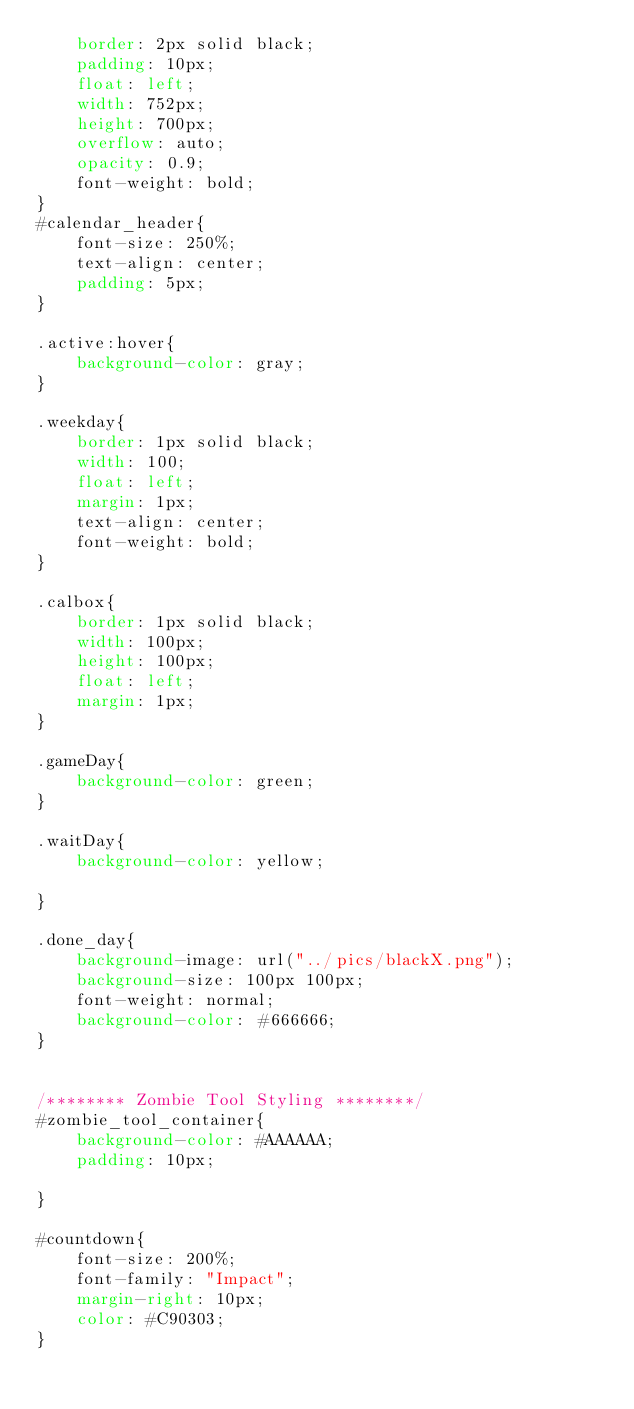<code> <loc_0><loc_0><loc_500><loc_500><_CSS_>	border: 2px solid black;
	padding: 10px;
	float: left;
	width: 752px;
	height: 700px;
	overflow: auto;
	opacity: 0.9;
	font-weight: bold;
}
#calendar_header{
	font-size: 250%;
	text-align: center;
	padding: 5px;
}

.active:hover{
	background-color: gray;
}

.weekday{
	border: 1px solid black;
	width: 100;
	float: left;
	margin: 1px;
	text-align: center;
	font-weight: bold;
}

.calbox{
	border: 1px solid black;
	width: 100px;
	height: 100px;
	float: left;
	margin: 1px;
}

.gameDay{
	background-color: green;
}

.waitDay{
	background-color: yellow;
	
}

.done_day{
	background-image: url("../pics/blackX.png");
	background-size: 100px 100px;
	font-weight: normal;
	background-color: #666666;
}


/******** Zombie Tool Styling ********/
#zombie_tool_container{
	background-color: #AAAAAA;
	padding: 10px;

}

#countdown{
	font-size: 200%;
	font-family: "Impact";
	margin-right: 10px;
	color: #C90303;
}</code> 